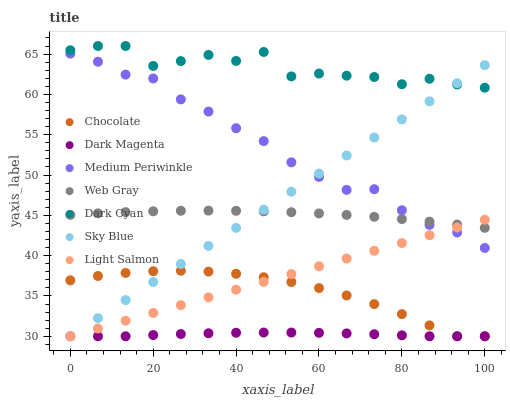Does Dark Magenta have the minimum area under the curve?
Answer yes or no. Yes. Does Dark Cyan have the maximum area under the curve?
Answer yes or no. Yes. Does Web Gray have the minimum area under the curve?
Answer yes or no. No. Does Web Gray have the maximum area under the curve?
Answer yes or no. No. Is Light Salmon the smoothest?
Answer yes or no. Yes. Is Dark Cyan the roughest?
Answer yes or no. Yes. Is Web Gray the smoothest?
Answer yes or no. No. Is Web Gray the roughest?
Answer yes or no. No. Does Light Salmon have the lowest value?
Answer yes or no. Yes. Does Web Gray have the lowest value?
Answer yes or no. No. Does Dark Cyan have the highest value?
Answer yes or no. Yes. Does Web Gray have the highest value?
Answer yes or no. No. Is Light Salmon less than Dark Cyan?
Answer yes or no. Yes. Is Medium Periwinkle greater than Dark Magenta?
Answer yes or no. Yes. Does Light Salmon intersect Medium Periwinkle?
Answer yes or no. Yes. Is Light Salmon less than Medium Periwinkle?
Answer yes or no. No. Is Light Salmon greater than Medium Periwinkle?
Answer yes or no. No. Does Light Salmon intersect Dark Cyan?
Answer yes or no. No. 